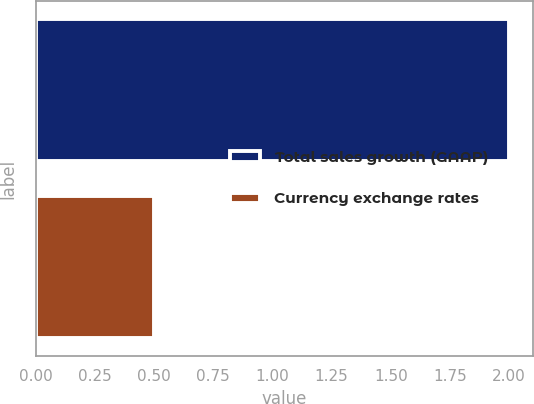<chart> <loc_0><loc_0><loc_500><loc_500><bar_chart><fcel>Total sales growth (GAAP)<fcel>Currency exchange rates<nl><fcel>2<fcel>0.5<nl></chart> 